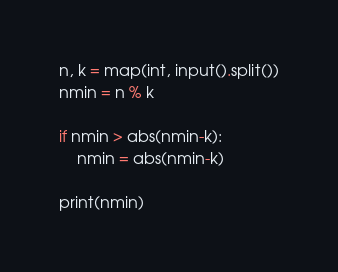<code> <loc_0><loc_0><loc_500><loc_500><_Python_>n, k = map(int, input().split())
nmin = n % k

if nmin > abs(nmin-k):
    nmin = abs(nmin-k)

print(nmin)
</code> 